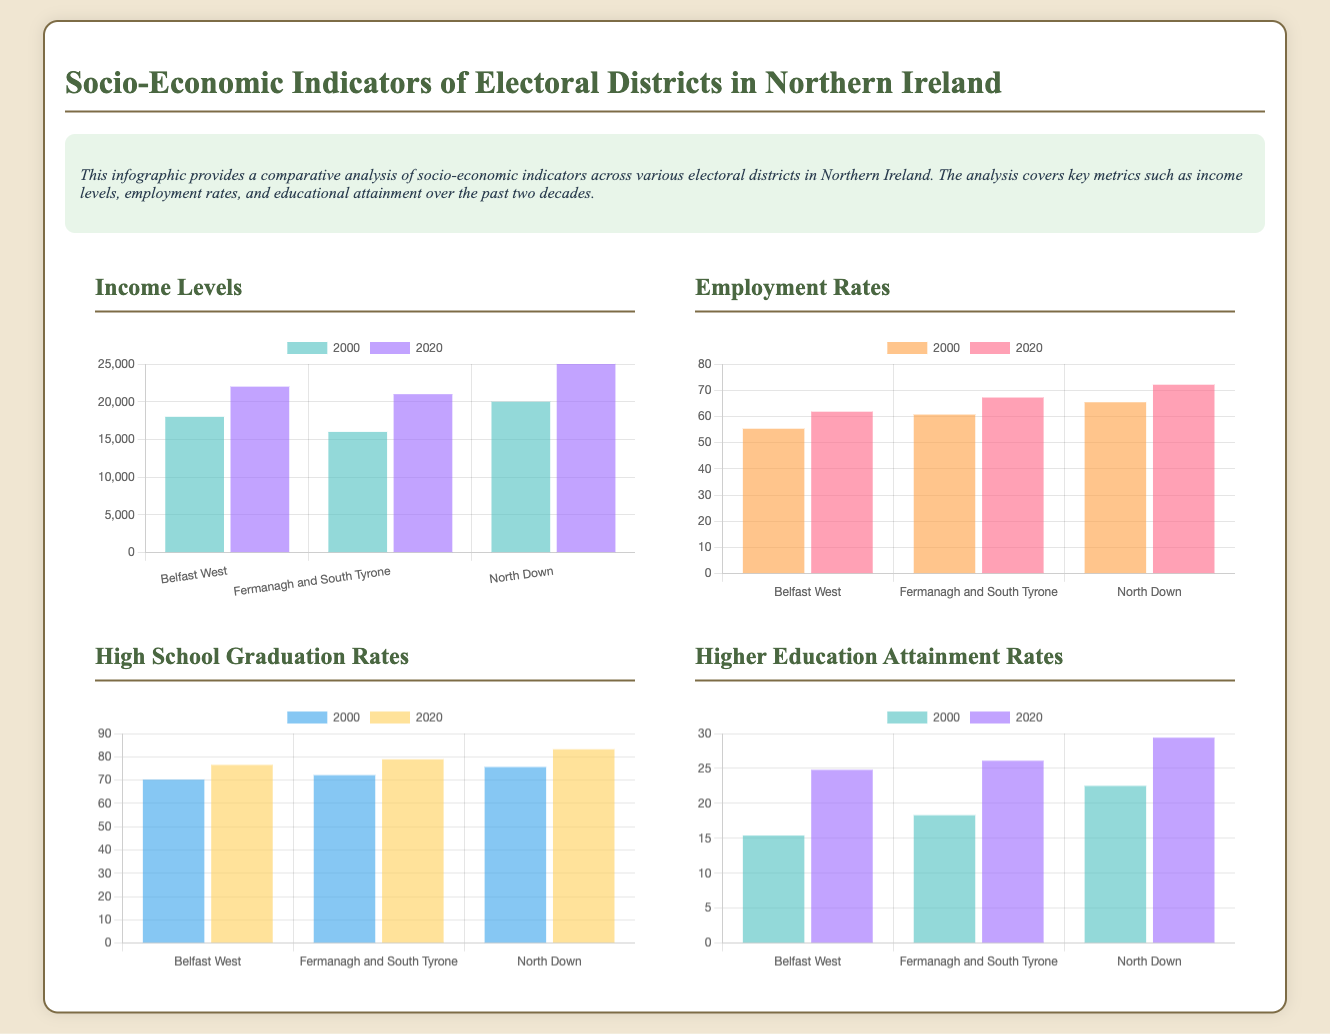What is the income level in North Down in 2000? The document states that the income level in North Down in 2000 is 20000.
Answer: 20000 What was the employment rate in Belfast West in 2020? According to the infographic, the employment rate in Belfast West in 2020 is 61.8.
Answer: 61.8 Which electoral district had the highest High School Graduation Rates in 2020? The radar chart indicates that North Down had the highest High School Graduation Rates in 2020, at 83.2.
Answer: North Down What is the percentage increase in Higher Education Attainment Rates from 2000 to 2020 in Fermanagh and South Tyrone? The percentage increase is calculated by subtracting the 2000 rate (18.3) from the 2020 rate (26.1), yielding an increase of 7.8.
Answer: 7.8 Which year showed a higher average income level across the three districts? By comparing the income levels from the chart, 2020 showed a higher average income across the districts than 2000.
Answer: 2020 What is the lowest recorded employment rate in 2000 among the districts listed? The document shows that the lowest recorded employment rate in 2000 was in Belfast West with 55.3.
Answer: 55.3 How many districts are compared in the document? The infographic compares three electoral districts: Belfast West, Fermanagh and South Tyrone, and North Down.
Answer: Three What type of chart is used to display employment rates? The employment rates are displayed using a bar chart format as indicated in the document.
Answer: Bar chart 